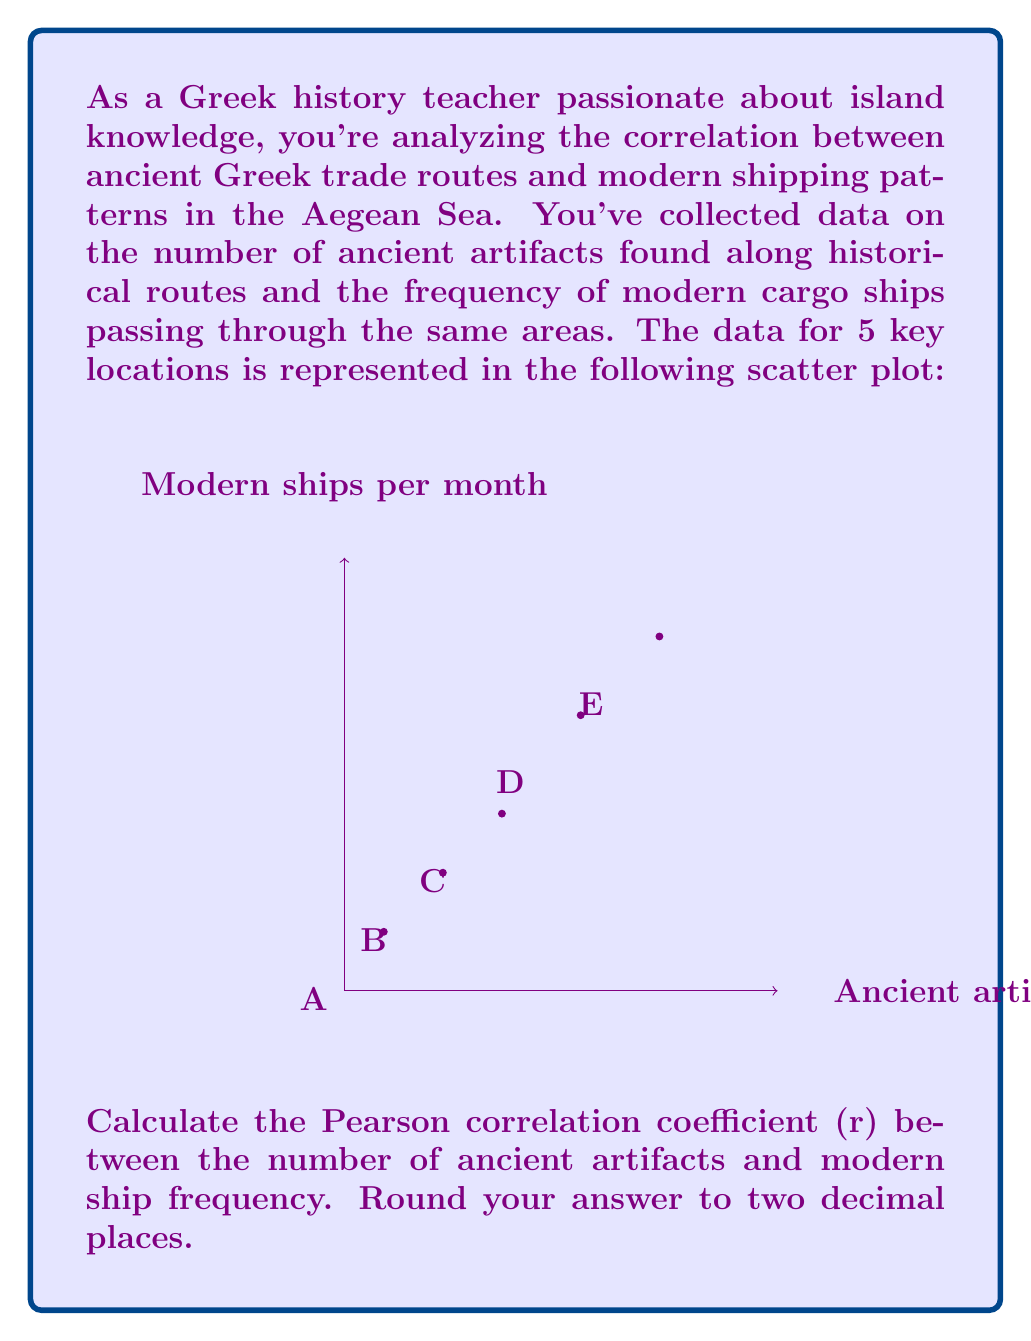Could you help me with this problem? To calculate the Pearson correlation coefficient (r), we'll use the formula:

$$ r = \frac{\sum_{i=1}^{n} (x_i - \bar{x})(y_i - \bar{y})}{\sqrt{\sum_{i=1}^{n} (x_i - \bar{x})^2} \sqrt{\sum_{i=1}^{n} (y_i - \bar{y})^2}} $$

Where:
$x_i$ and $y_i$ are the individual sample points
$\bar{x}$ and $\bar{y}$ are the sample means

Step 1: Calculate the means
$\bar{x} = \frac{10 + 25 + 40 + 60 + 80}{5} = 43$
$\bar{y} = \frac{15 + 30 + 45 + 70 + 90}{5} = 50$

Step 2: Calculate $(x_i - \bar{x})$, $(y_i - \bar{y})$, $(x_i - \bar{x})^2$, $(y_i - \bar{y})^2$, and $(x_i - \bar{x})(y_i - \bar{y})$

| $x_i$ | $y_i$ | $x_i - \bar{x}$ | $y_i - \bar{y}$ | $(x_i - \bar{x})^2$ | $(y_i - \bar{y})^2$ | $(x_i - \bar{x})(y_i - \bar{y})$ |
|-------|-------|-----------------|-----------------|---------------------|---------------------|----------------------------------|
| 10    | 15    | -33             | -35             | 1089                | 1225                | 1155                             |
| 25    | 30    | -18             | -20             | 324                 | 400                 | 360                              |
| 40    | 45    | -3              | -5              | 9                   | 25                  | 15                               |
| 60    | 70    | 17              | 20              | 289                 | 400                 | 340                              |
| 80    | 90    | 37              | 40              | 1369                | 1600                | 1480                             |

Step 3: Sum the columns
$\sum (x_i - \bar{x})(y_i - \bar{y}) = 3350$
$\sum (x_i - \bar{x})^2 = 3080$
$\sum (y_i - \bar{y})^2 = 3650$

Step 4: Apply the formula
$$ r = \frac{3350}{\sqrt{3080} \sqrt{3650}} = \frac{3350}{\sqrt{11242000}} = \frac{3350}{3352.90} \approx 0.9991 $$

Step 5: Round to two decimal places
$r \approx 1.00$
Answer: 1.00 